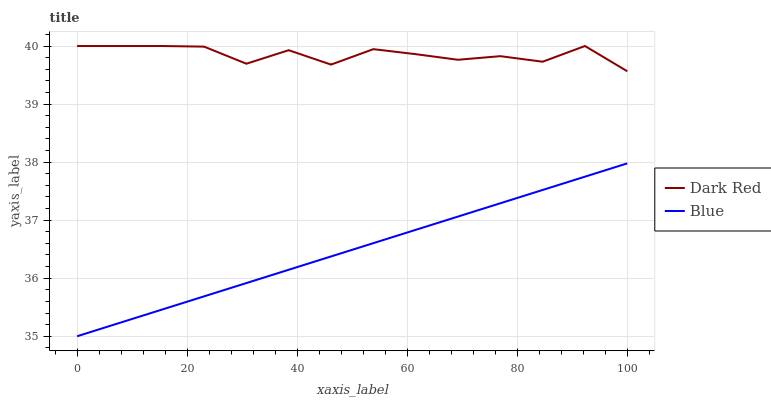Does Blue have the minimum area under the curve?
Answer yes or no. Yes. Does Dark Red have the maximum area under the curve?
Answer yes or no. Yes. Does Dark Red have the minimum area under the curve?
Answer yes or no. No. Is Blue the smoothest?
Answer yes or no. Yes. Is Dark Red the roughest?
Answer yes or no. Yes. Is Dark Red the smoothest?
Answer yes or no. No. Does Blue have the lowest value?
Answer yes or no. Yes. Does Dark Red have the lowest value?
Answer yes or no. No. Does Dark Red have the highest value?
Answer yes or no. Yes. Is Blue less than Dark Red?
Answer yes or no. Yes. Is Dark Red greater than Blue?
Answer yes or no. Yes. Does Blue intersect Dark Red?
Answer yes or no. No. 